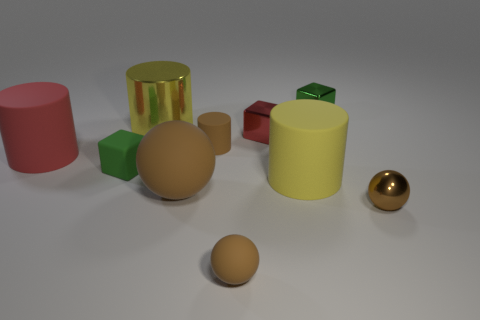There is a big rubber object that is the same color as the small matte ball; what is its shape?
Make the answer very short. Sphere. What number of red objects have the same size as the brown cylinder?
Offer a terse response. 1. There is a large matte thing on the left side of the big ball; what is its shape?
Offer a very short reply. Cylinder. Is the number of green things less than the number of large cubes?
Your response must be concise. No. Are there any other things of the same color as the small metal ball?
Offer a terse response. Yes. What size is the yellow thing that is behind the large red rubber object?
Provide a short and direct response. Large. Are there more large blue rubber cylinders than large red cylinders?
Provide a short and direct response. No. What material is the red cube?
Keep it short and to the point. Metal. What number of other things are the same material as the brown cylinder?
Give a very brief answer. 5. How many yellow metal objects are there?
Your response must be concise. 1. 